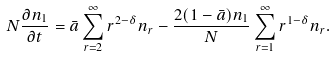Convert formula to latex. <formula><loc_0><loc_0><loc_500><loc_500>N \frac { \partial n _ { 1 } } { \partial t } = \bar { a } \sum _ { r = 2 } ^ { \infty } r ^ { 2 - \delta } n _ { r } - \frac { 2 ( 1 - \bar { a } ) n _ { 1 } } { N } \sum _ { r = 1 } ^ { \infty } r ^ { 1 - \delta } n _ { r } .</formula> 